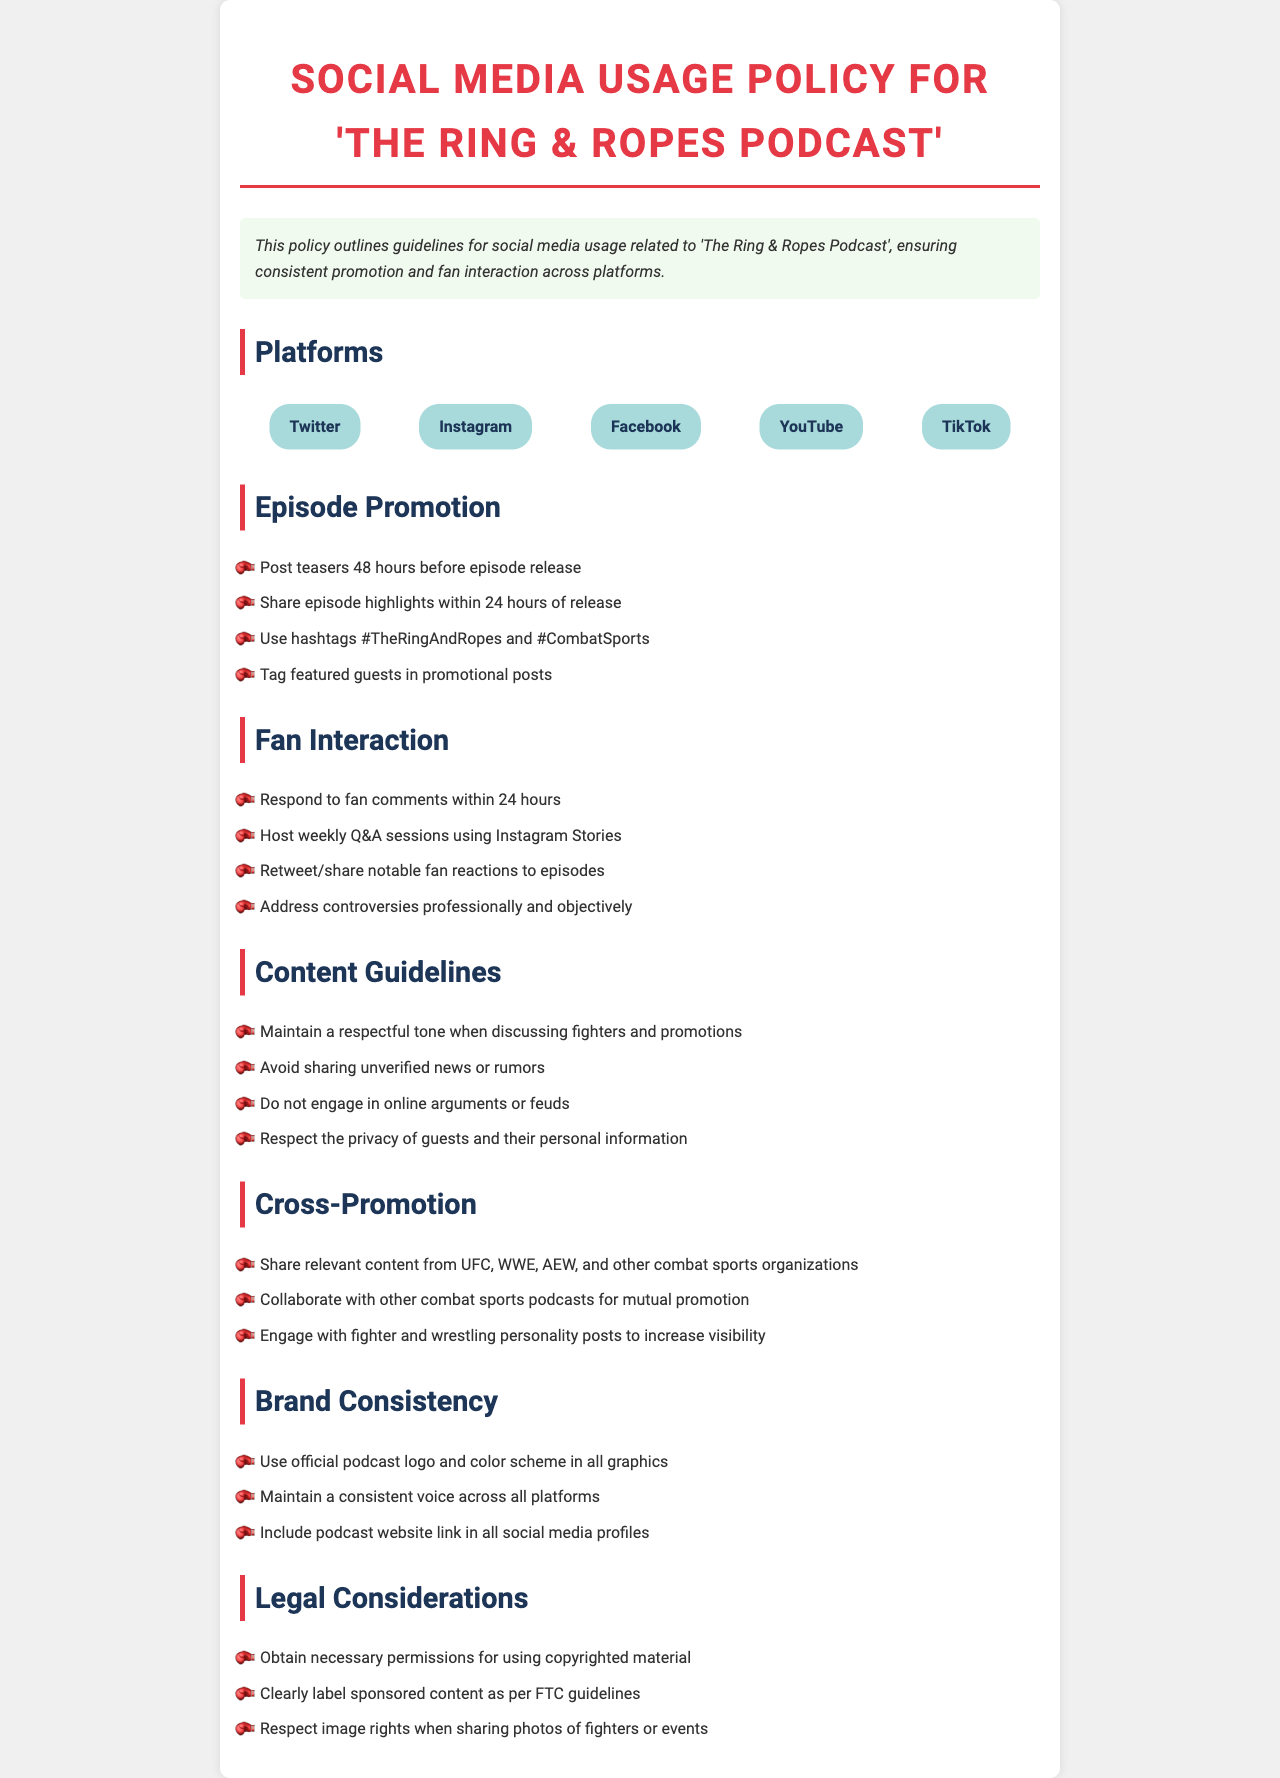What are the platforms listed in the policy? The platforms are mentioned in the 'Platforms' section and include Twitter, Instagram, Facebook, YouTube, and TikTok.
Answer: Twitter, Instagram, Facebook, YouTube, TikTok How soon should episode teasers be posted? The policy specifies posting teasers 48 hours before episode release in the 'Episode Promotion' section.
Answer: 48 hours What should be included in promotional posts? The policy mentions tagging featured guests in promotional posts, which is a crucial guideline in the 'Episode Promotion' section.
Answer: Tag featured guests What is the response time for fan comments? The policy states to respond to fan comments within 24 hours, found in the 'Fan Interaction' section.
Answer: 24 hours Which organizations should content be shared from? The 'Cross-Promotion' section specifies sharing relevant content from UFC, WWE, AEW, and other combat sports organizations.
Answer: UFC, WWE, AEW What is a key requirement for sponsored content? In the 'Legal Considerations' section, it mentions clearly labeling sponsored content as per FTC guidelines.
Answer: Clearly label What tone should be maintained when discussing fighters? The 'Content Guidelines' section specifies maintaining a respectful tone when discussing fighters and promotions.
Answer: Respectful tone What should be included in all social media profiles? The 'Brand Consistency' section states to include the podcast website link in all social media profiles.
Answer: Podcast website link 